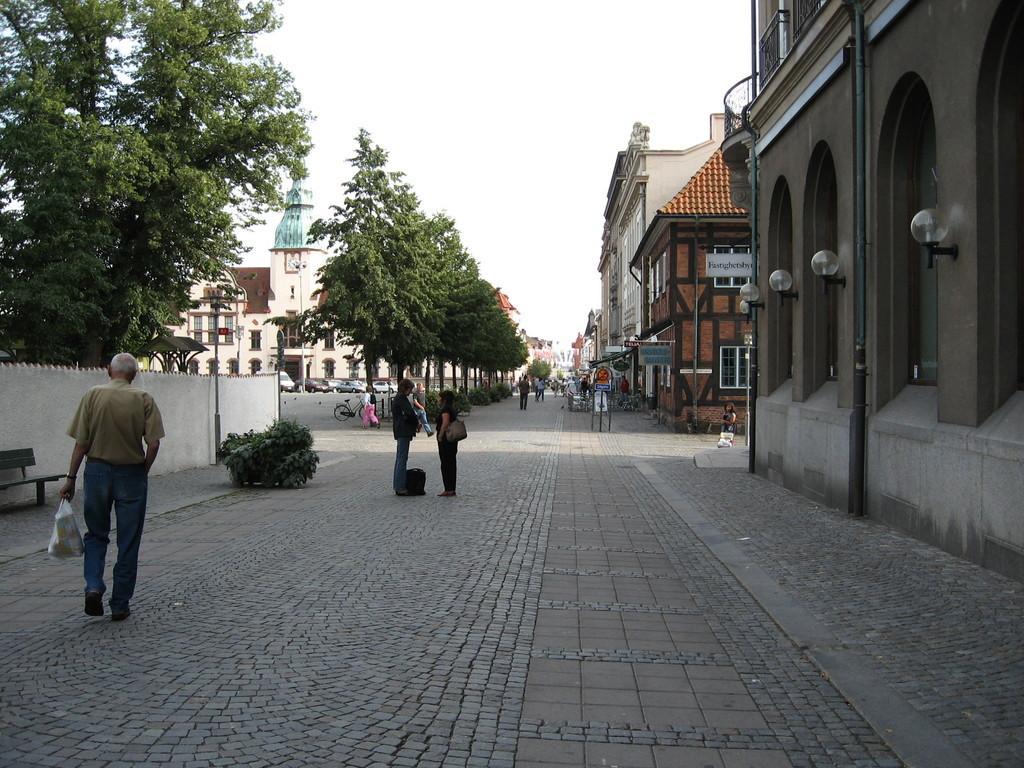In one or two sentences, can you explain what this image depicts? This is an outside view. Here I can see few people standing and walking on the road. On the left side there is a man holding a bag in the hand and walking towards the back side. On both sides of the road there are poles, trees and buildings. At the top of the image I can see the sky. 